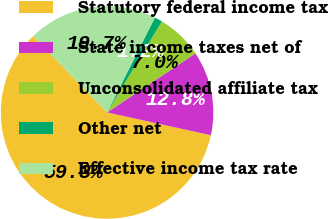Convert chart. <chart><loc_0><loc_0><loc_500><loc_500><pie_chart><fcel>Statutory federal income tax<fcel>State income taxes net of<fcel>Unconsolidated affiliate tax<fcel>Other net<fcel>Effective income tax rate<nl><fcel>59.33%<fcel>12.82%<fcel>7.0%<fcel>1.19%<fcel>19.66%<nl></chart> 